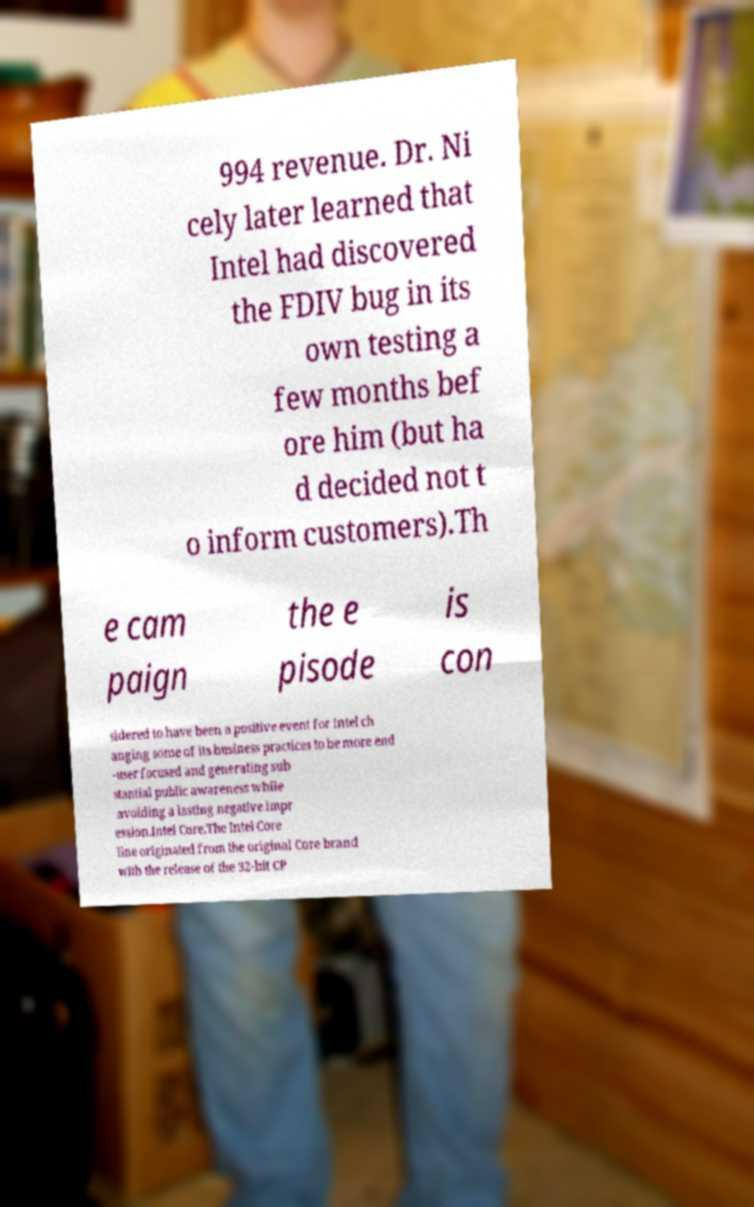What messages or text are displayed in this image? I need them in a readable, typed format. 994 revenue. Dr. Ni cely later learned that Intel had discovered the FDIV bug in its own testing a few months bef ore him (but ha d decided not t o inform customers).Th e cam paign the e pisode is con sidered to have been a positive event for Intel ch anging some of its business practices to be more end -user focused and generating sub stantial public awareness while avoiding a lasting negative impr ession.Intel Core.The Intel Core line originated from the original Core brand with the release of the 32-bit CP 